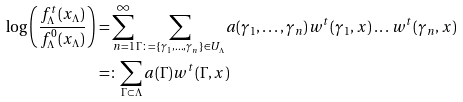Convert formula to latex. <formula><loc_0><loc_0><loc_500><loc_500>\log \left ( \frac { f ^ { t } _ { \Lambda } ( x _ { \Lambda } ) } { f ^ { 0 } _ { \Lambda } ( x _ { \Lambda } ) } \right ) & = \sum _ { n = 1 } ^ { \infty } \sum _ { \Gamma \colon = \{ \gamma _ { 1 } , \dots , \gamma _ { n } \} \in U _ { \Lambda } } a ( \gamma _ { 1 } , \dots , \gamma _ { n } ) w ^ { t } ( \gamma _ { 1 } , x ) \dots w ^ { t } ( \gamma _ { n } , x ) \\ & = \colon \sum _ { \Gamma \subset \Lambda } a ( \Gamma ) w ^ { t } ( \Gamma , x )</formula> 